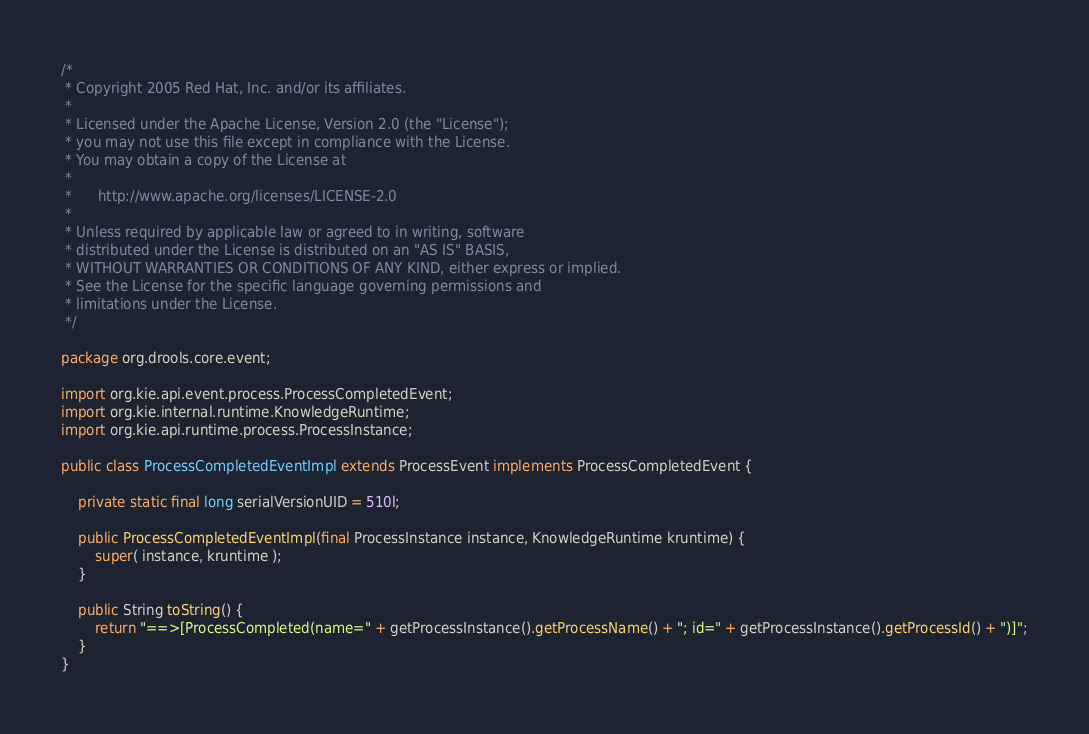Convert code to text. <code><loc_0><loc_0><loc_500><loc_500><_Java_>/*
 * Copyright 2005 Red Hat, Inc. and/or its affiliates.
 *
 * Licensed under the Apache License, Version 2.0 (the "License");
 * you may not use this file except in compliance with the License.
 * You may obtain a copy of the License at
 *
 *      http://www.apache.org/licenses/LICENSE-2.0
 *
 * Unless required by applicable law or agreed to in writing, software
 * distributed under the License is distributed on an "AS IS" BASIS,
 * WITHOUT WARRANTIES OR CONDITIONS OF ANY KIND, either express or implied.
 * See the License for the specific language governing permissions and
 * limitations under the License.
 */

package org.drools.core.event;

import org.kie.api.event.process.ProcessCompletedEvent;
import org.kie.internal.runtime.KnowledgeRuntime;
import org.kie.api.runtime.process.ProcessInstance;

public class ProcessCompletedEventImpl extends ProcessEvent implements ProcessCompletedEvent {

    private static final long serialVersionUID = 510l;

    public ProcessCompletedEventImpl(final ProcessInstance instance, KnowledgeRuntime kruntime) {
        super( instance, kruntime );
    }

    public String toString() {
        return "==>[ProcessCompleted(name=" + getProcessInstance().getProcessName() + "; id=" + getProcessInstance().getProcessId() + ")]";
    }
}
</code> 